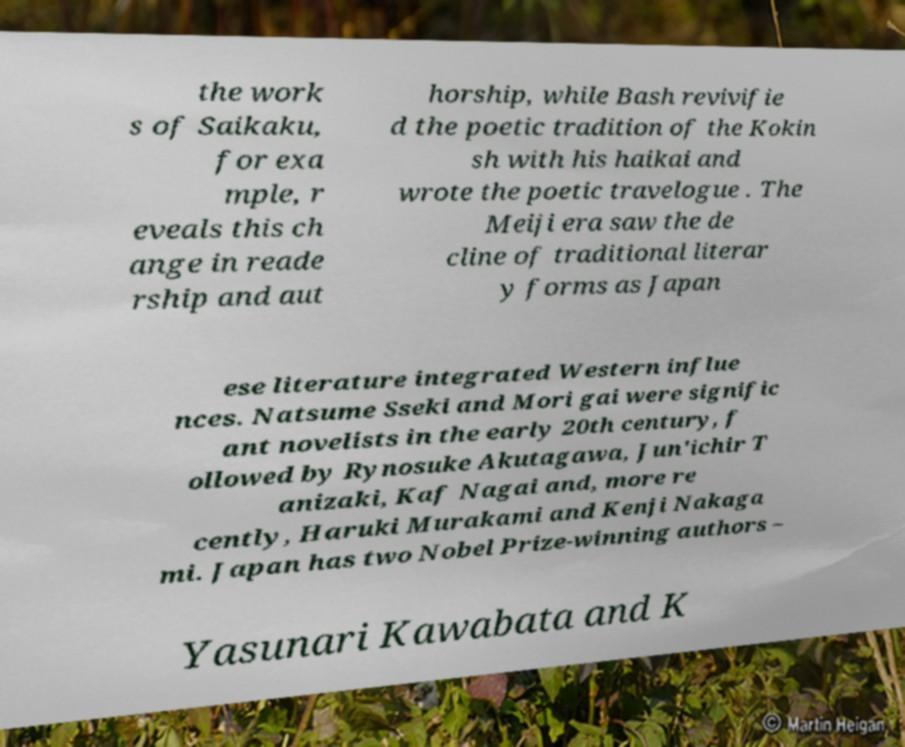Please identify and transcribe the text found in this image. the work s of Saikaku, for exa mple, r eveals this ch ange in reade rship and aut horship, while Bash revivifie d the poetic tradition of the Kokin sh with his haikai and wrote the poetic travelogue . The Meiji era saw the de cline of traditional literar y forms as Japan ese literature integrated Western influe nces. Natsume Sseki and Mori gai were signific ant novelists in the early 20th century, f ollowed by Rynosuke Akutagawa, Jun'ichir T anizaki, Kaf Nagai and, more re cently, Haruki Murakami and Kenji Nakaga mi. Japan has two Nobel Prize-winning authors – Yasunari Kawabata and K 